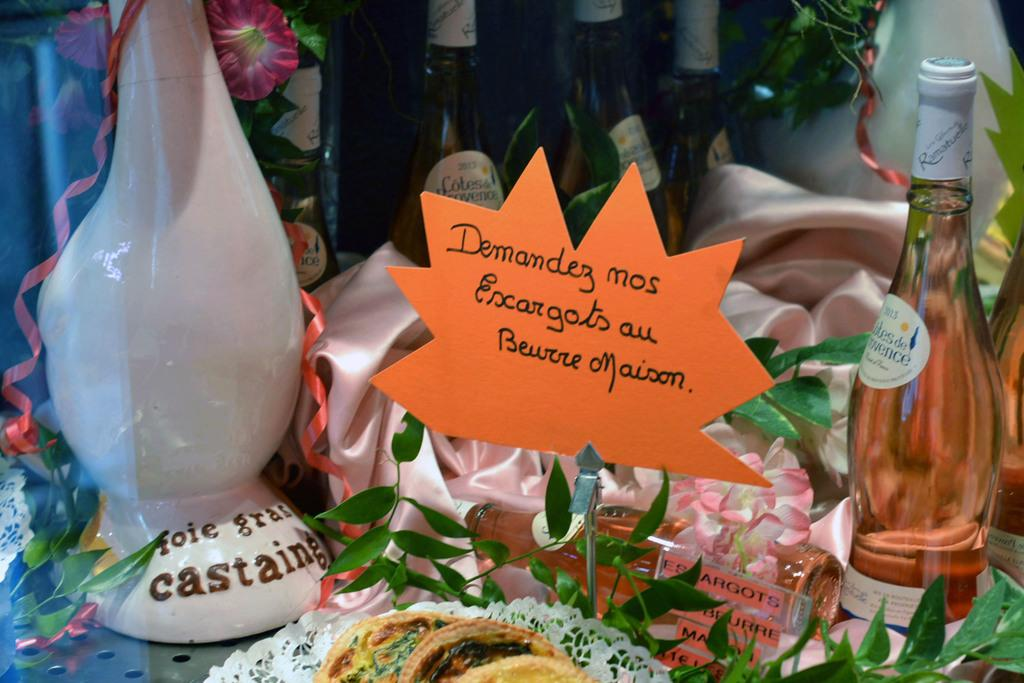<image>
Give a short and clear explanation of the subsequent image. A display of bottles and figures along with a sign for demandez mos encargots au. 